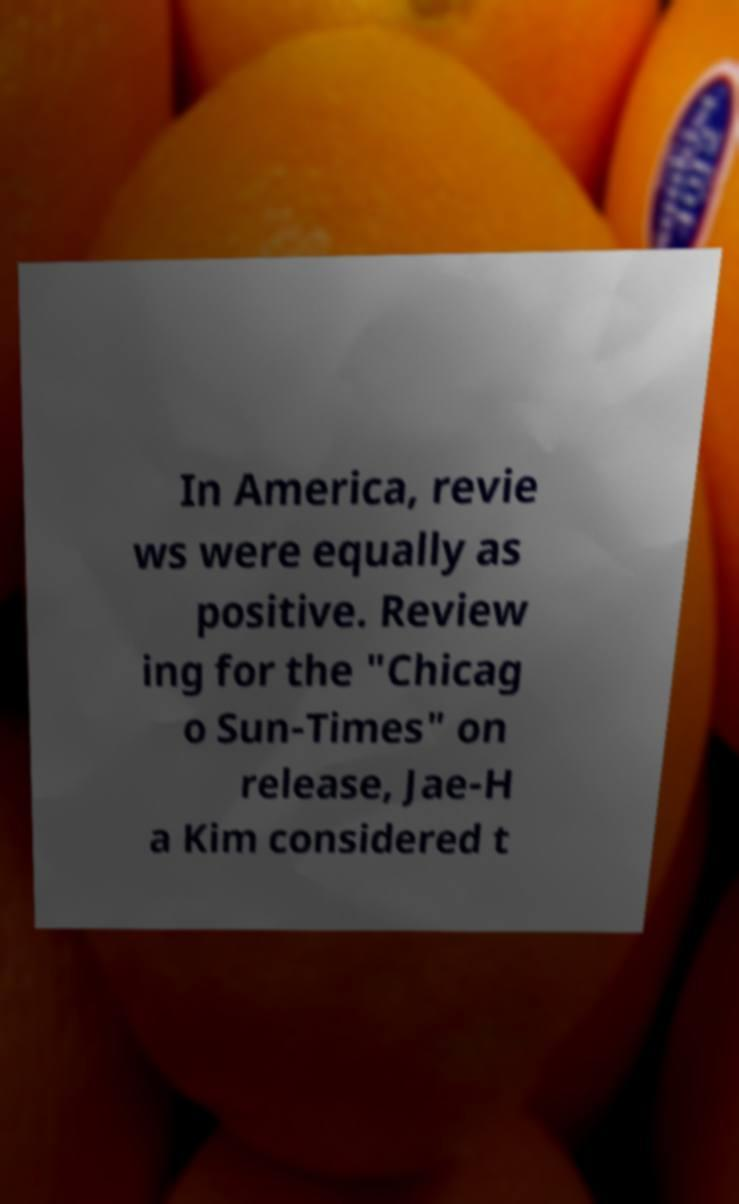Please identify and transcribe the text found in this image. In America, revie ws were equally as positive. Review ing for the "Chicag o Sun-Times" on release, Jae-H a Kim considered t 